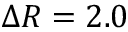Convert formula to latex. <formula><loc_0><loc_0><loc_500><loc_500>\Delta R = 2 . 0</formula> 